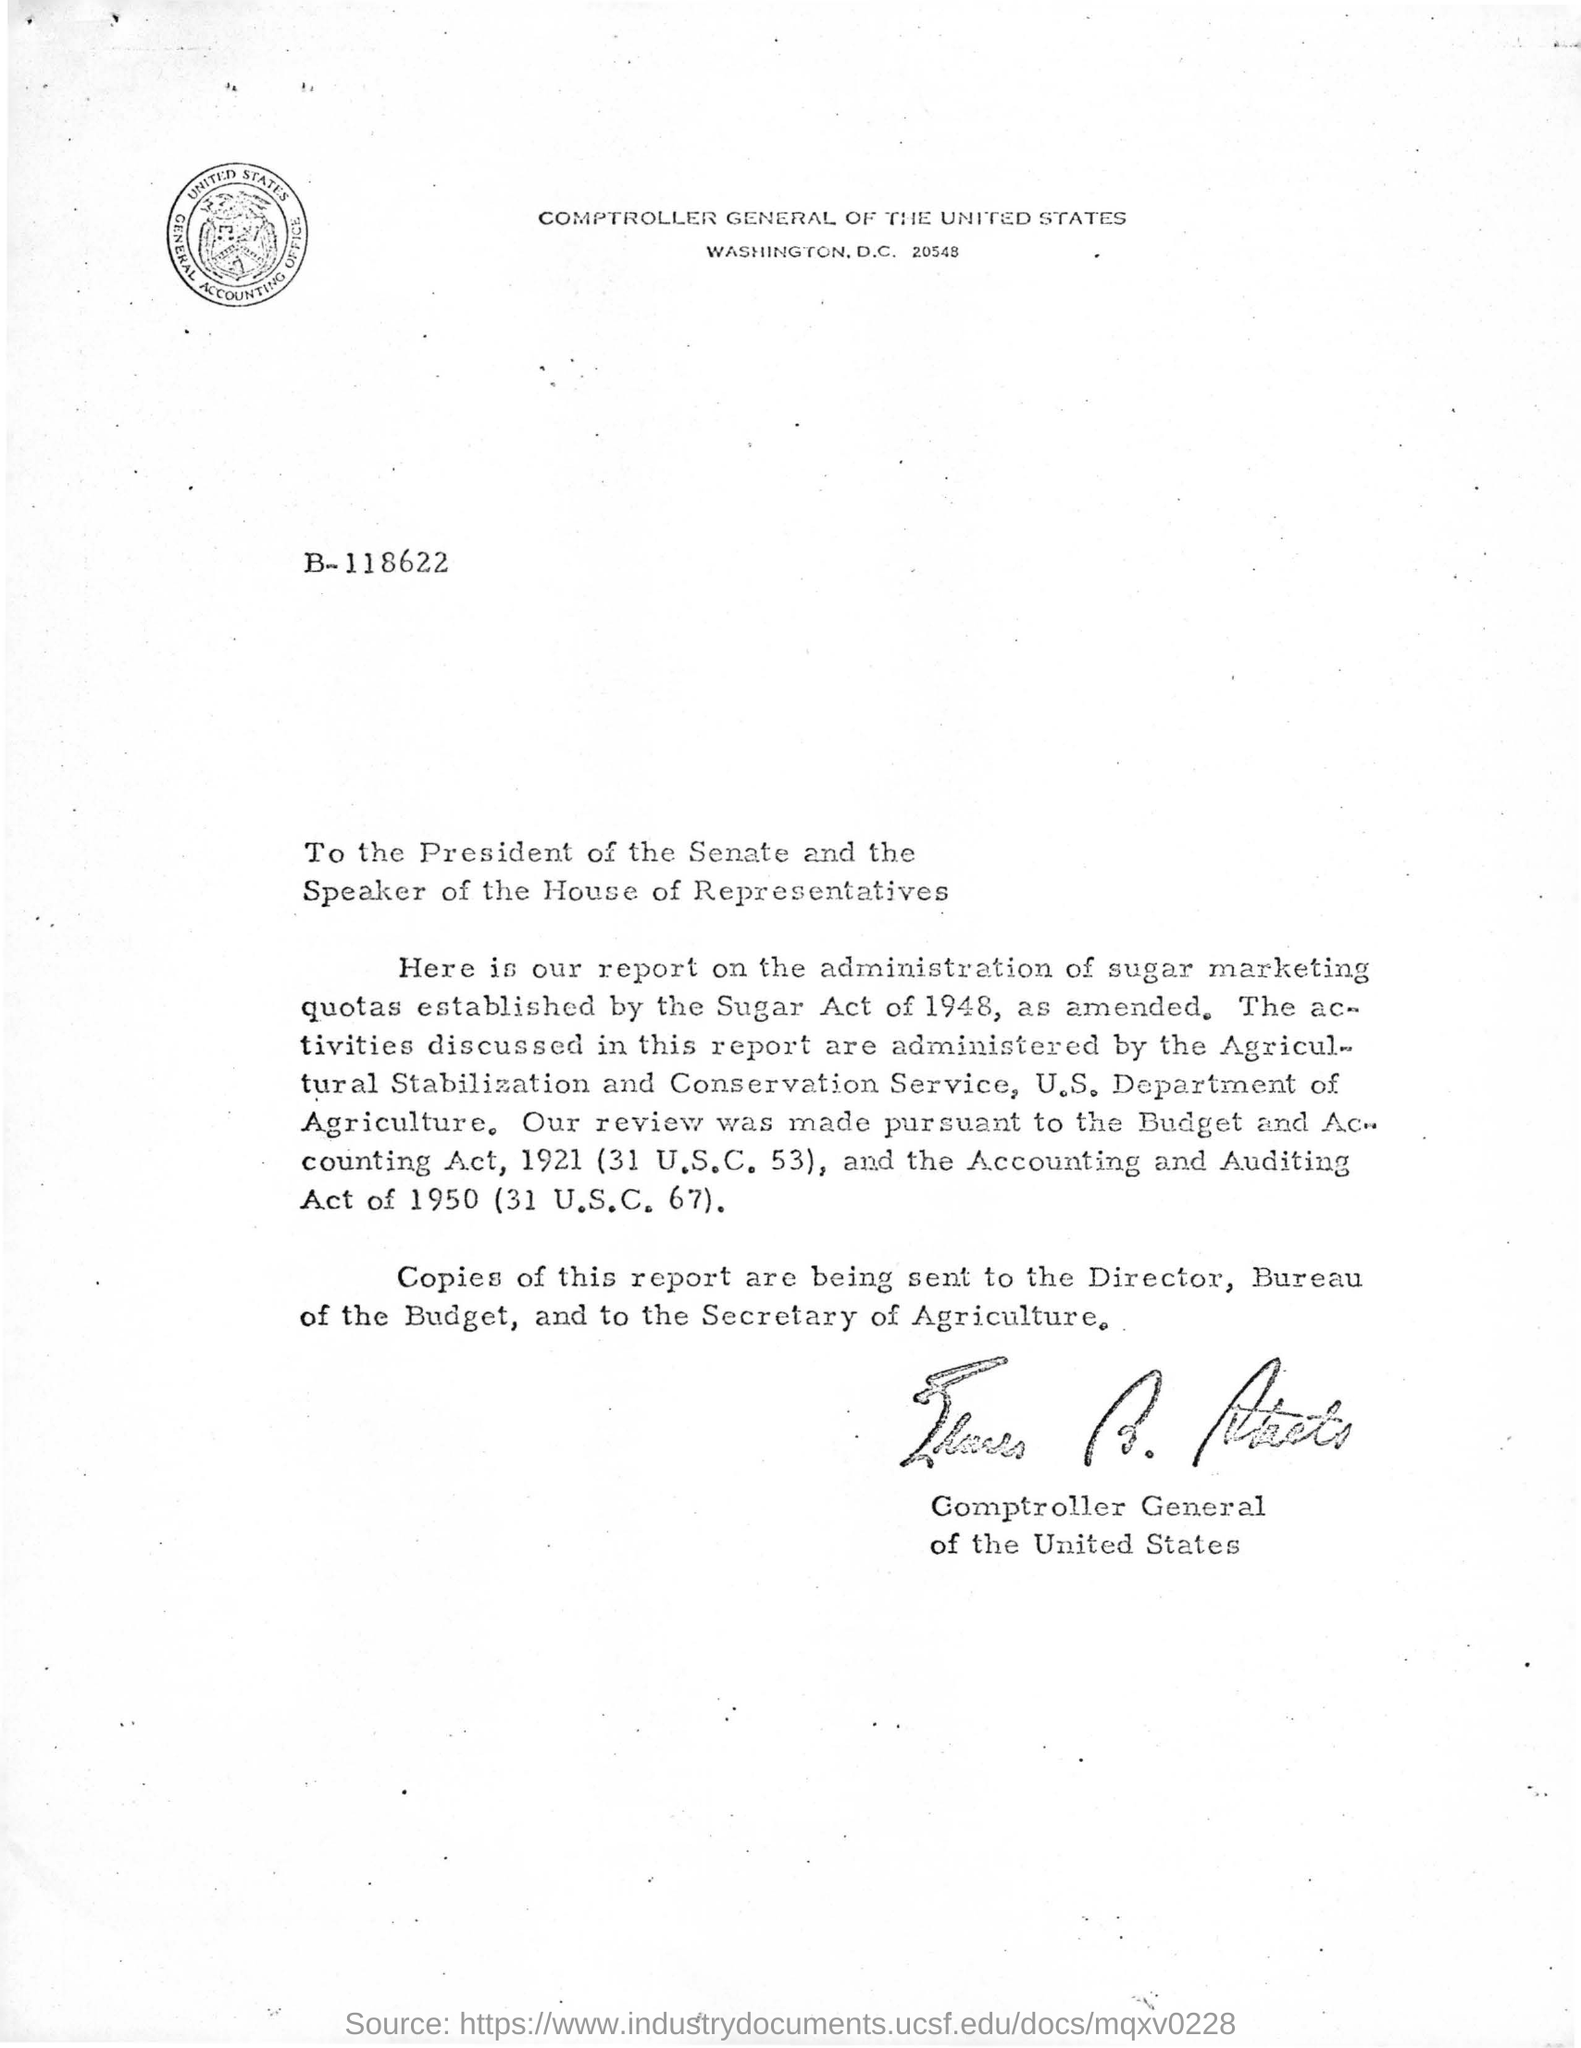Identify some key points in this picture. The Agricultural Stabilization and Conservation Service administered the activities discussed in the report. The Comptroller General of the United States signed the letter in question. The secretary of agriculture is the recipient of a copy of the letter. The Accounting and Auditing Act (31 U.S.C. 67) came into force in 1950. 